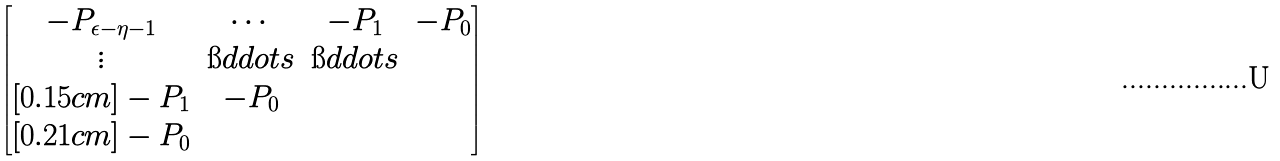Convert formula to latex. <formula><loc_0><loc_0><loc_500><loc_500>\begin{bmatrix} - P _ { \epsilon - \eta - 1 } & \cdots & - P _ { 1 } & - P _ { 0 } \\ \vdots & \i d d o t s & \i d d o t s & \\ [ 0 . 1 5 c m ] - P _ { 1 } & - P _ { 0 } & & \\ [ 0 . 2 1 c m ] - P _ { 0 } & & & \end{bmatrix}</formula> 